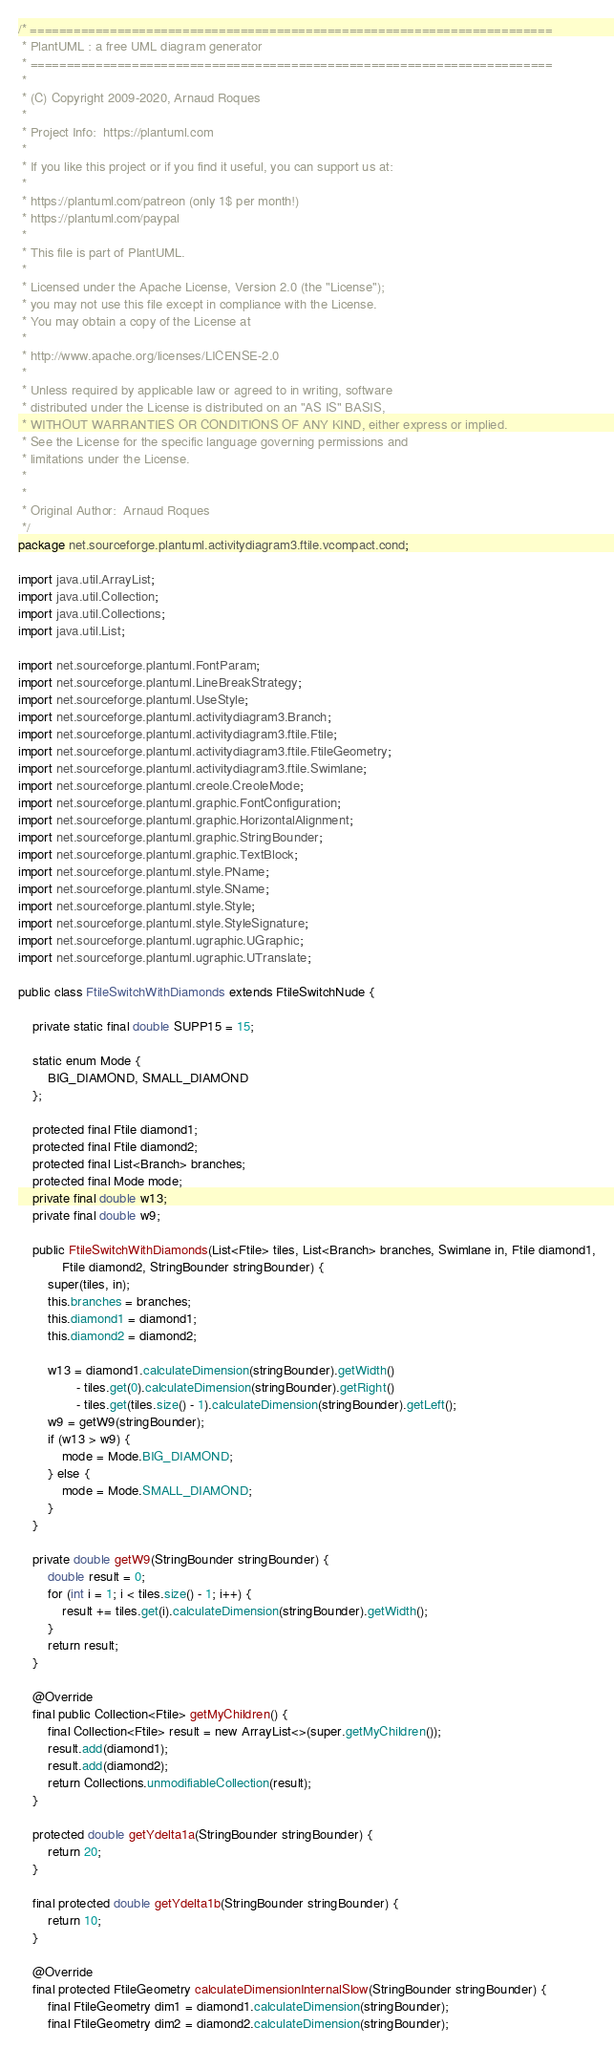<code> <loc_0><loc_0><loc_500><loc_500><_Java_>/* ========================================================================
 * PlantUML : a free UML diagram generator
 * ========================================================================
 *
 * (C) Copyright 2009-2020, Arnaud Roques
 *
 * Project Info:  https://plantuml.com
 * 
 * If you like this project or if you find it useful, you can support us at:
 * 
 * https://plantuml.com/patreon (only 1$ per month!)
 * https://plantuml.com/paypal
 * 
 * This file is part of PlantUML.
 *
 * Licensed under the Apache License, Version 2.0 (the "License");
 * you may not use this file except in compliance with the License.
 * You may obtain a copy of the License at
 * 
 * http://www.apache.org/licenses/LICENSE-2.0
 * 
 * Unless required by applicable law or agreed to in writing, software
 * distributed under the License is distributed on an "AS IS" BASIS,
 * WITHOUT WARRANTIES OR CONDITIONS OF ANY KIND, either express or implied.
 * See the License for the specific language governing permissions and
 * limitations under the License.
 *
 *
 * Original Author:  Arnaud Roques
 */
package net.sourceforge.plantuml.activitydiagram3.ftile.vcompact.cond;

import java.util.ArrayList;
import java.util.Collection;
import java.util.Collections;
import java.util.List;

import net.sourceforge.plantuml.FontParam;
import net.sourceforge.plantuml.LineBreakStrategy;
import net.sourceforge.plantuml.UseStyle;
import net.sourceforge.plantuml.activitydiagram3.Branch;
import net.sourceforge.plantuml.activitydiagram3.ftile.Ftile;
import net.sourceforge.plantuml.activitydiagram3.ftile.FtileGeometry;
import net.sourceforge.plantuml.activitydiagram3.ftile.Swimlane;
import net.sourceforge.plantuml.creole.CreoleMode;
import net.sourceforge.plantuml.graphic.FontConfiguration;
import net.sourceforge.plantuml.graphic.HorizontalAlignment;
import net.sourceforge.plantuml.graphic.StringBounder;
import net.sourceforge.plantuml.graphic.TextBlock;
import net.sourceforge.plantuml.style.PName;
import net.sourceforge.plantuml.style.SName;
import net.sourceforge.plantuml.style.Style;
import net.sourceforge.plantuml.style.StyleSignature;
import net.sourceforge.plantuml.ugraphic.UGraphic;
import net.sourceforge.plantuml.ugraphic.UTranslate;

public class FtileSwitchWithDiamonds extends FtileSwitchNude {

	private static final double SUPP15 = 15;

	static enum Mode {
		BIG_DIAMOND, SMALL_DIAMOND
	};

	protected final Ftile diamond1;
	protected final Ftile diamond2;
	protected final List<Branch> branches;
	protected final Mode mode;
	private final double w13;
	private final double w9;

	public FtileSwitchWithDiamonds(List<Ftile> tiles, List<Branch> branches, Swimlane in, Ftile diamond1,
			Ftile diamond2, StringBounder stringBounder) {
		super(tiles, in);
		this.branches = branches;
		this.diamond1 = diamond1;
		this.diamond2 = diamond2;

		w13 = diamond1.calculateDimension(stringBounder).getWidth()
				- tiles.get(0).calculateDimension(stringBounder).getRight()
				- tiles.get(tiles.size() - 1).calculateDimension(stringBounder).getLeft();
		w9 = getW9(stringBounder);
		if (w13 > w9) {
			mode = Mode.BIG_DIAMOND;
		} else {
			mode = Mode.SMALL_DIAMOND;
		}
	}

	private double getW9(StringBounder stringBounder) {
		double result = 0;
		for (int i = 1; i < tiles.size() - 1; i++) {
			result += tiles.get(i).calculateDimension(stringBounder).getWidth();
		}
		return result;
	}

	@Override
	final public Collection<Ftile> getMyChildren() {
		final Collection<Ftile> result = new ArrayList<>(super.getMyChildren());
		result.add(diamond1);
		result.add(diamond2);
		return Collections.unmodifiableCollection(result);
	}

	protected double getYdelta1a(StringBounder stringBounder) {
		return 20;
	}

	final protected double getYdelta1b(StringBounder stringBounder) {
		return 10;
	}

	@Override
	final protected FtileGeometry calculateDimensionInternalSlow(StringBounder stringBounder) {
		final FtileGeometry dim1 = diamond1.calculateDimension(stringBounder);
		final FtileGeometry dim2 = diamond2.calculateDimension(stringBounder);
</code> 